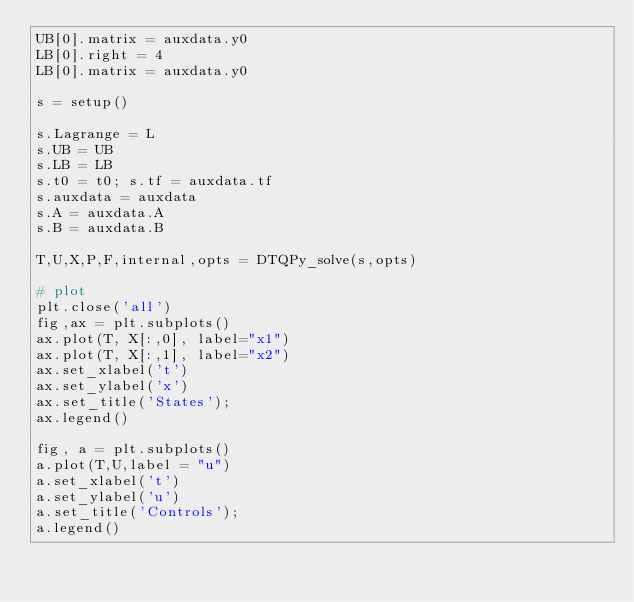Convert code to text. <code><loc_0><loc_0><loc_500><loc_500><_Python_>UB[0].matrix = auxdata.y0
LB[0].right = 4
LB[0].matrix = auxdata.y0

s = setup()

s.Lagrange = L
s.UB = UB
s.LB = LB
s.t0 = t0; s.tf = auxdata.tf
s.auxdata = auxdata
s.A = auxdata.A
s.B = auxdata.B

T,U,X,P,F,internal,opts = DTQPy_solve(s,opts) 

# plot
plt.close('all')
fig,ax = plt.subplots()
ax.plot(T, X[:,0], label="x1")
ax.plot(T, X[:,1], label="x2")
ax.set_xlabel('t')
ax.set_ylabel('x')
ax.set_title('States');
ax.legend()

fig, a = plt.subplots()
a.plot(T,U,label = "u")
a.set_xlabel('t')
a.set_ylabel('u')
a.set_title('Controls');
a.legend()</code> 